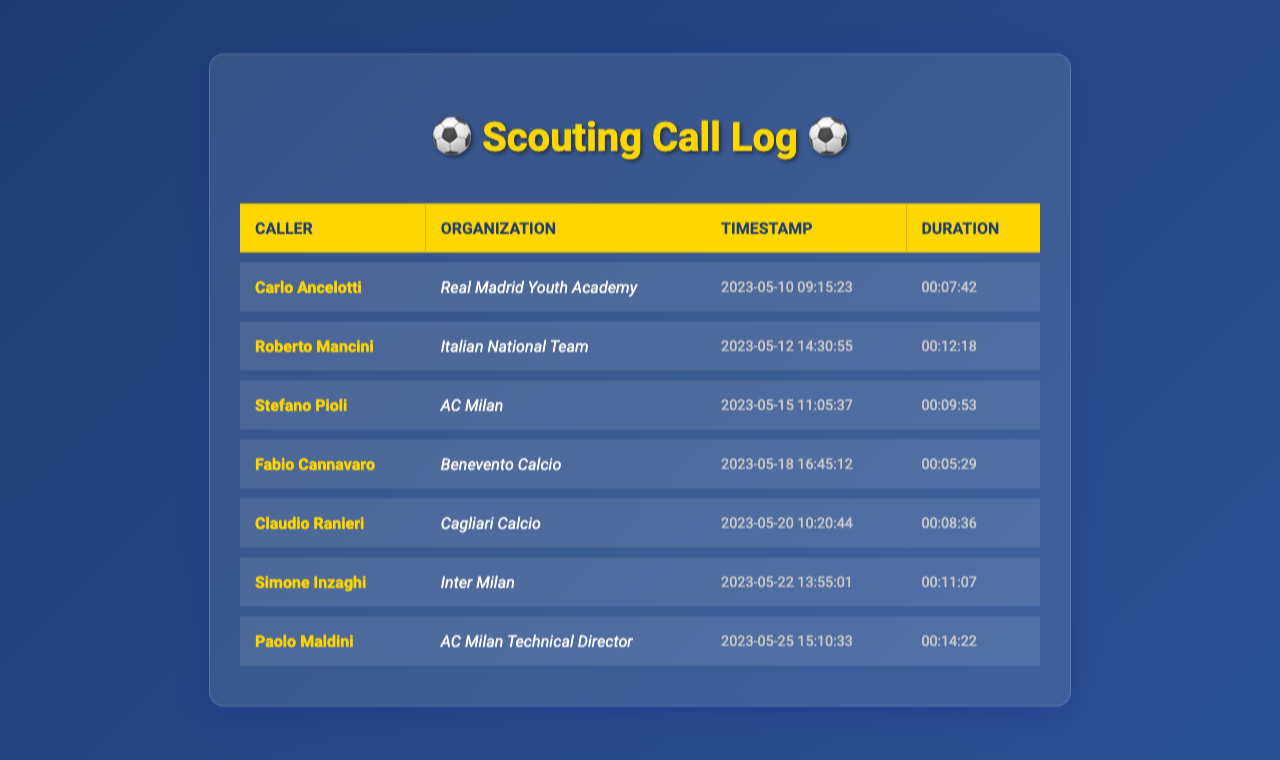What is the name of the caller on May 12, 2023? The document lists Roberto Mancini as the caller on that date.
Answer: Roberto Mancini Which organization is associated with Carlo Ancelotti? The document states that Carlo Ancelotti is associated with the Real Madrid Youth Academy.
Answer: Real Madrid Youth Academy What was the duration of the call from Paolo Maldini? The document indicates that the call from Paolo Maldini lasted for 14 minutes and 22 seconds.
Answer: 00:14:22 How many calls were made on May 20, 2023? The document shows that only one call was listed on May 20, 2023, from Claudio Ranieri.
Answer: 1 Who called on May 22, 2023? According to the document, Simone Inzaghi made the call on that date.
Answer: Simone Inzaghi What time did Fabio Cannavaro call? The document records that Fabio Cannavaro called at 16:45:12.
Answer: 16:45:12 Which organization called with the longest duration? The longest call duration was from Paolo Maldini, according to the recorded times in the document.
Answer: AC Milan Technical Director 